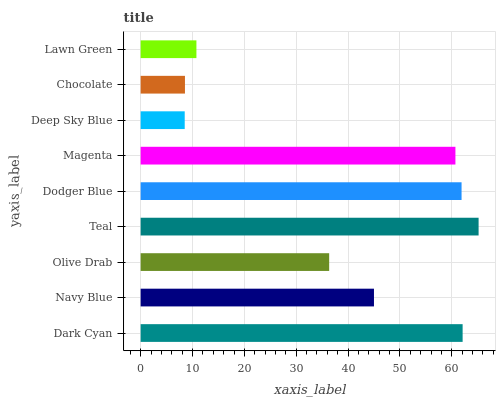Is Deep Sky Blue the minimum?
Answer yes or no. Yes. Is Teal the maximum?
Answer yes or no. Yes. Is Navy Blue the minimum?
Answer yes or no. No. Is Navy Blue the maximum?
Answer yes or no. No. Is Dark Cyan greater than Navy Blue?
Answer yes or no. Yes. Is Navy Blue less than Dark Cyan?
Answer yes or no. Yes. Is Navy Blue greater than Dark Cyan?
Answer yes or no. No. Is Dark Cyan less than Navy Blue?
Answer yes or no. No. Is Navy Blue the high median?
Answer yes or no. Yes. Is Navy Blue the low median?
Answer yes or no. Yes. Is Dark Cyan the high median?
Answer yes or no. No. Is Deep Sky Blue the low median?
Answer yes or no. No. 